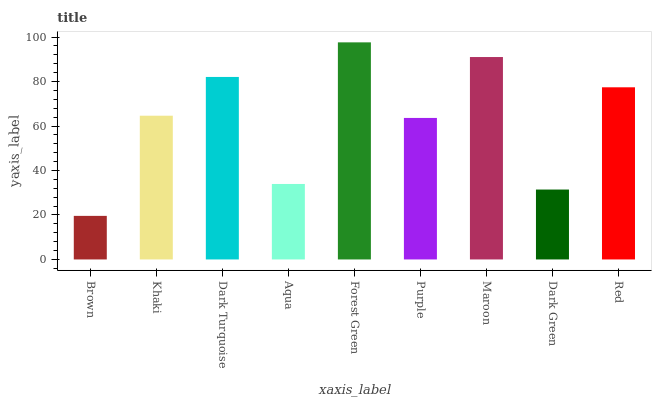Is Khaki the minimum?
Answer yes or no. No. Is Khaki the maximum?
Answer yes or no. No. Is Khaki greater than Brown?
Answer yes or no. Yes. Is Brown less than Khaki?
Answer yes or no. Yes. Is Brown greater than Khaki?
Answer yes or no. No. Is Khaki less than Brown?
Answer yes or no. No. Is Khaki the high median?
Answer yes or no. Yes. Is Khaki the low median?
Answer yes or no. Yes. Is Brown the high median?
Answer yes or no. No. Is Purple the low median?
Answer yes or no. No. 